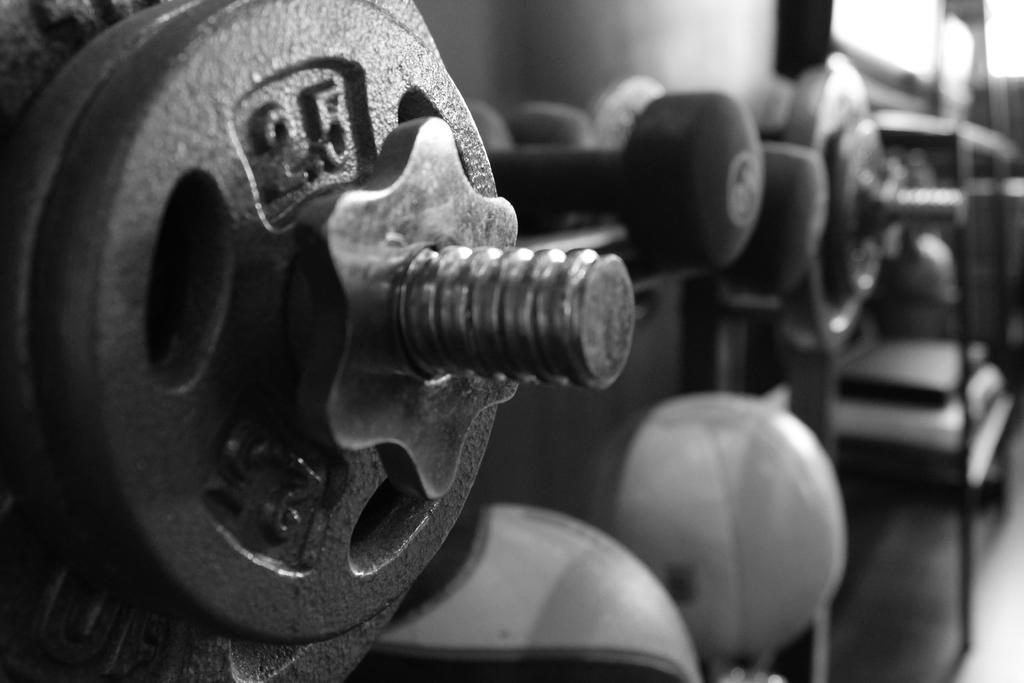What is the color scheme of the image? The image is in black and white. What type of exercise equipment can be seen in the image? There are dumbbells and weight plates in the image. What is the purpose of the rack to the right in the image? The rack is likely used for storing or organizing the exercise equipment. What are the balls at the bottom of the image used for? The balls at the bottom of the image may be used for weightlifting or other exercises. What is visible behind the objects in the image? There is a wall behind the objects in the image. What type of yard can be seen in the image? There is no yard visible in the image; it features exercise equipment and a wall. How does the image look from a different angle? The image is a still photograph and cannot be viewed from a different angle. 